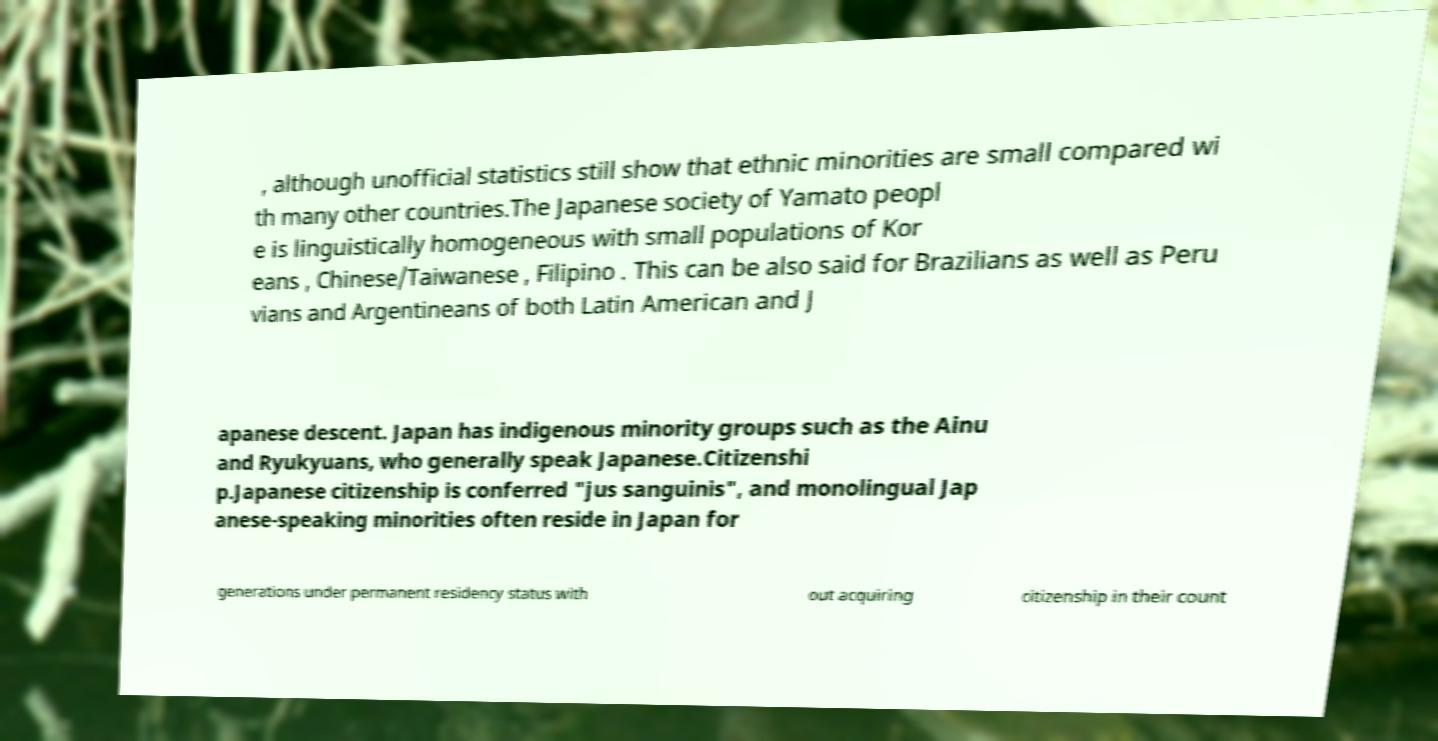Could you assist in decoding the text presented in this image and type it out clearly? , although unofficial statistics still show that ethnic minorities are small compared wi th many other countries.The Japanese society of Yamato peopl e is linguistically homogeneous with small populations of Kor eans , Chinese/Taiwanese , Filipino . This can be also said for Brazilians as well as Peru vians and Argentineans of both Latin American and J apanese descent. Japan has indigenous minority groups such as the Ainu and Ryukyuans, who generally speak Japanese.Citizenshi p.Japanese citizenship is conferred "jus sanguinis", and monolingual Jap anese-speaking minorities often reside in Japan for generations under permanent residency status with out acquiring citizenship in their count 